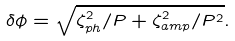Convert formula to latex. <formula><loc_0><loc_0><loc_500><loc_500>\delta \phi = \sqrt { \zeta _ { p h } ^ { 2 } / P + \zeta _ { a m p } ^ { 2 } / P ^ { 2 } } .</formula> 